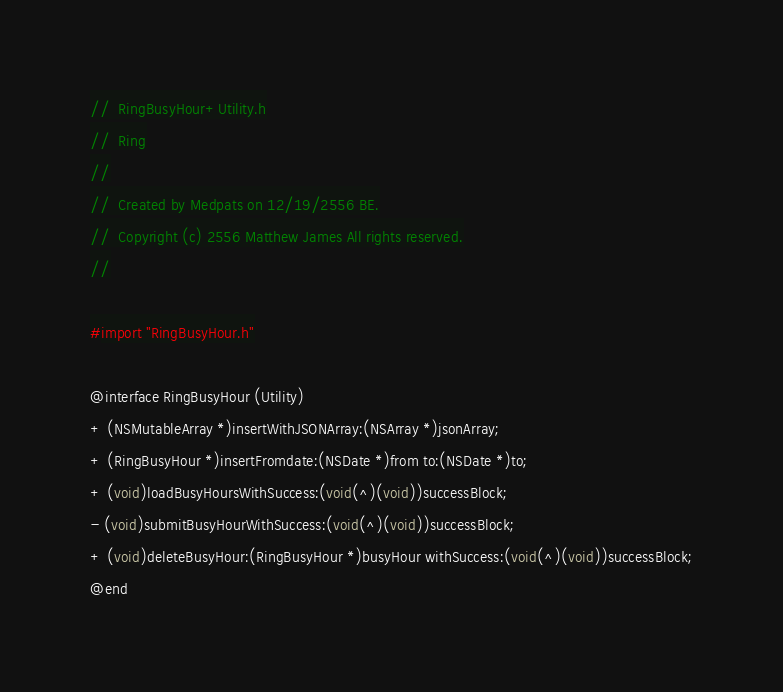Convert code to text. <code><loc_0><loc_0><loc_500><loc_500><_C_>//  RingBusyHour+Utility.h
//  Ring
//
//  Created by Medpats on 12/19/2556 BE.
//  Copyright (c) 2556 Matthew James All rights reserved.
//

#import "RingBusyHour.h"

@interface RingBusyHour (Utility)
+ (NSMutableArray *)insertWithJSONArray:(NSArray *)jsonArray;
+ (RingBusyHour *)insertFromdate:(NSDate *)from to:(NSDate *)to;
+ (void)loadBusyHoursWithSuccess:(void(^)(void))successBlock;
- (void)submitBusyHourWithSuccess:(void(^)(void))successBlock;
+ (void)deleteBusyHour:(RingBusyHour *)busyHour withSuccess:(void(^)(void))successBlock;
@end
</code> 